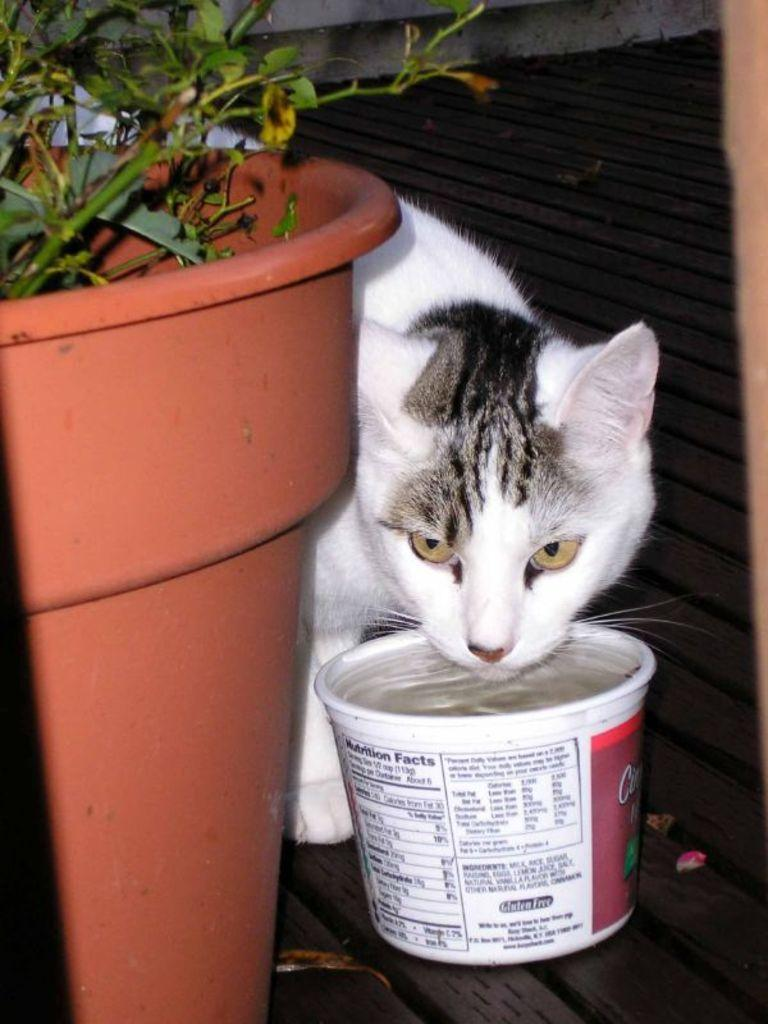What type of plant can be seen in the image? There is a house plant in the image. What animal is present in the image? There is a cat in the image. What object is on the ground in the image? There is a box on the ground in the image. What can be seen in the background of the image? There is a wall in the background of the image. How many jewels are on the cat's collar in the image? There is no mention of a collar or jewels in the image; it features a cat, a house plant, a box, and a wall in the background. 